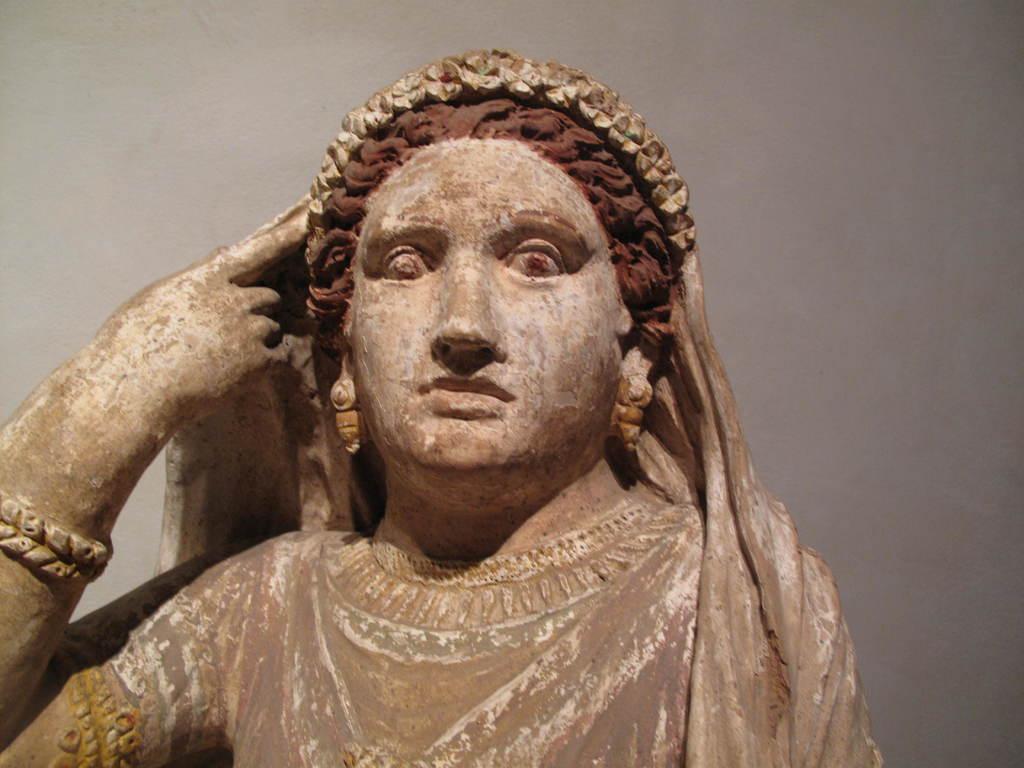In one or two sentences, can you explain what this image depicts? In the foreground I can see a sculpture of a woman. The background is white in color. This image is taken may be in a hall. 